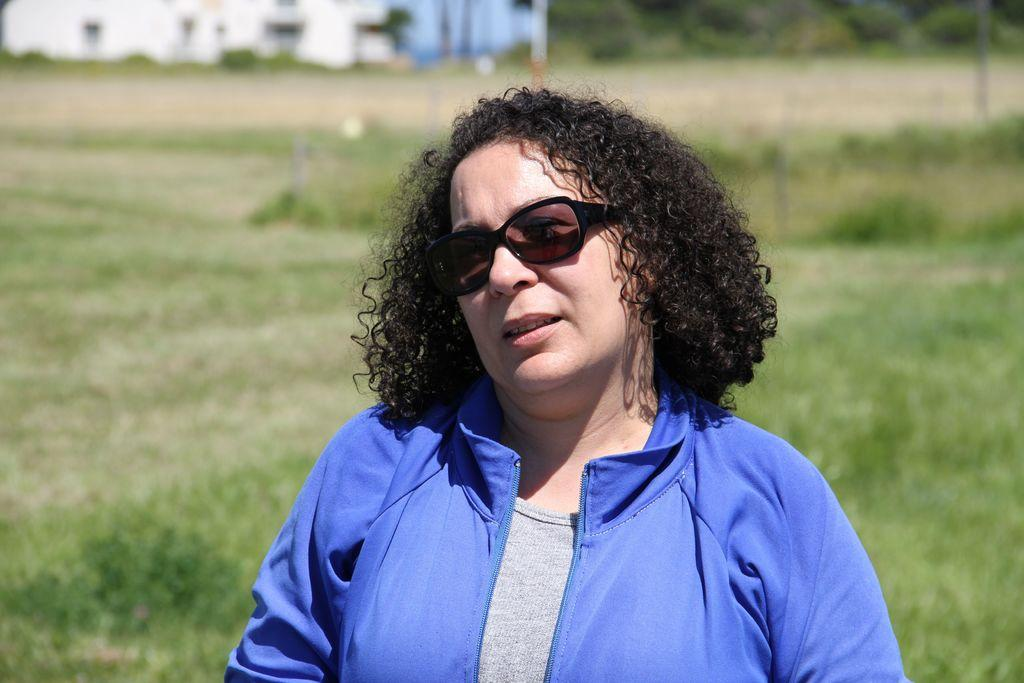What can be seen in the image? There is a person in the image. Can you describe the person's clothing? The person is wearing blue and ash-colored clothing. What accessory is the person wearing? The person is wearing specs. Where is the person located in the image? The person is on the ground. What can be seen in the background of the image? There are trees and a blurry building in the background of the image. What type of poison is the person holding in the image? There is no poison present in the image; the person is wearing specs and is on the ground. How many bikes are visible in the image? There are no bikes present in the image. 